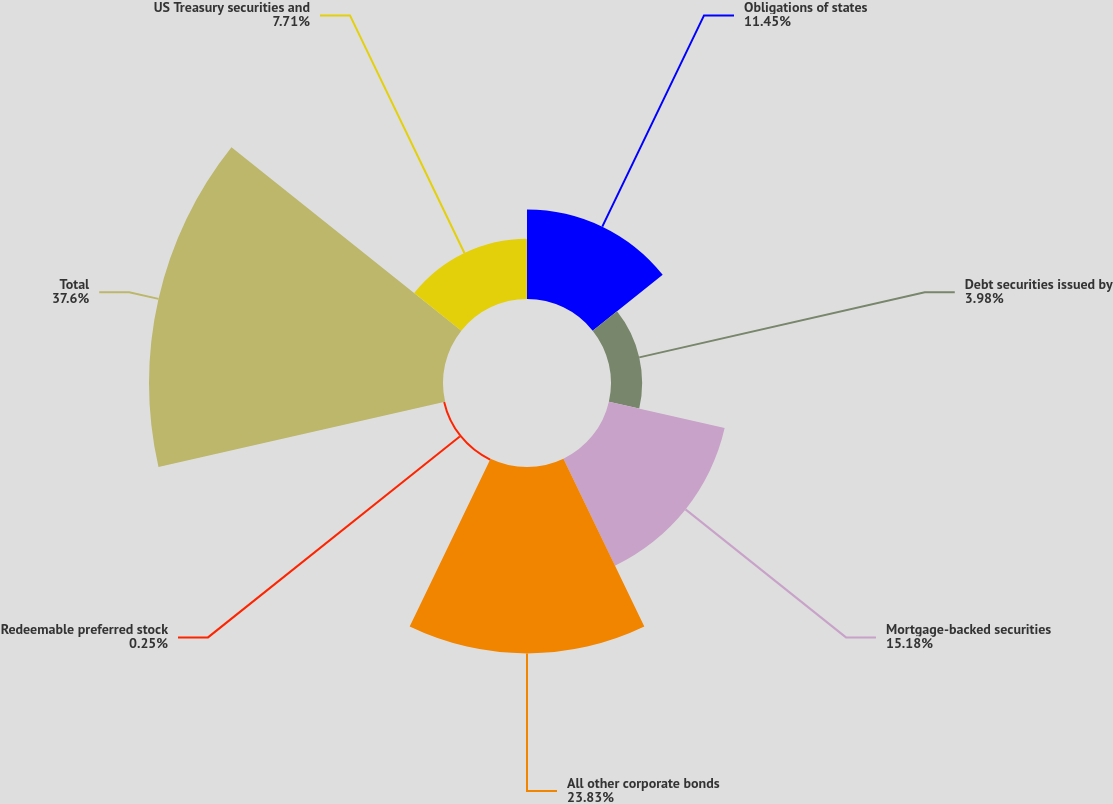<chart> <loc_0><loc_0><loc_500><loc_500><pie_chart><fcel>Obligations of states<fcel>Debt securities issued by<fcel>Mortgage-backed securities<fcel>All other corporate bonds<fcel>Redeemable preferred stock<fcel>Total<fcel>US Treasury securities and<nl><fcel>11.45%<fcel>3.98%<fcel>15.18%<fcel>23.83%<fcel>0.25%<fcel>37.59%<fcel>7.71%<nl></chart> 